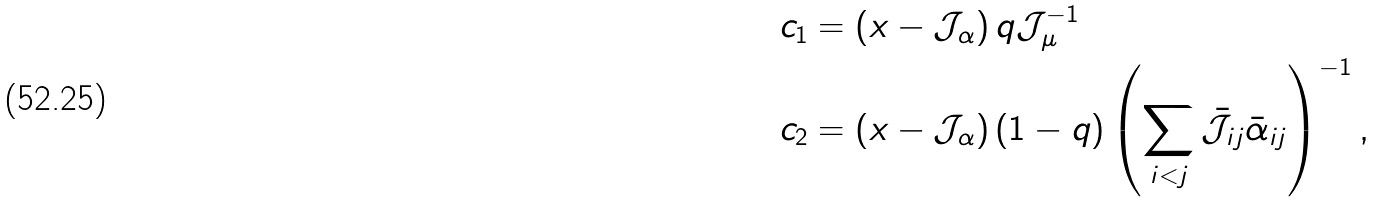<formula> <loc_0><loc_0><loc_500><loc_500>& c _ { 1 } = \left ( x - \mathcal { J } _ { \alpha } \right ) q \mathcal { J } _ { \mu } ^ { - 1 } \\ & c _ { 2 } = \left ( x - \mathcal { J } _ { \alpha } \right ) ( 1 - q ) \left ( \sum _ { i < j } \bar { \mathcal { J } } _ { i j } \bar { \alpha } _ { i j } \right ) ^ { - 1 } ,</formula> 